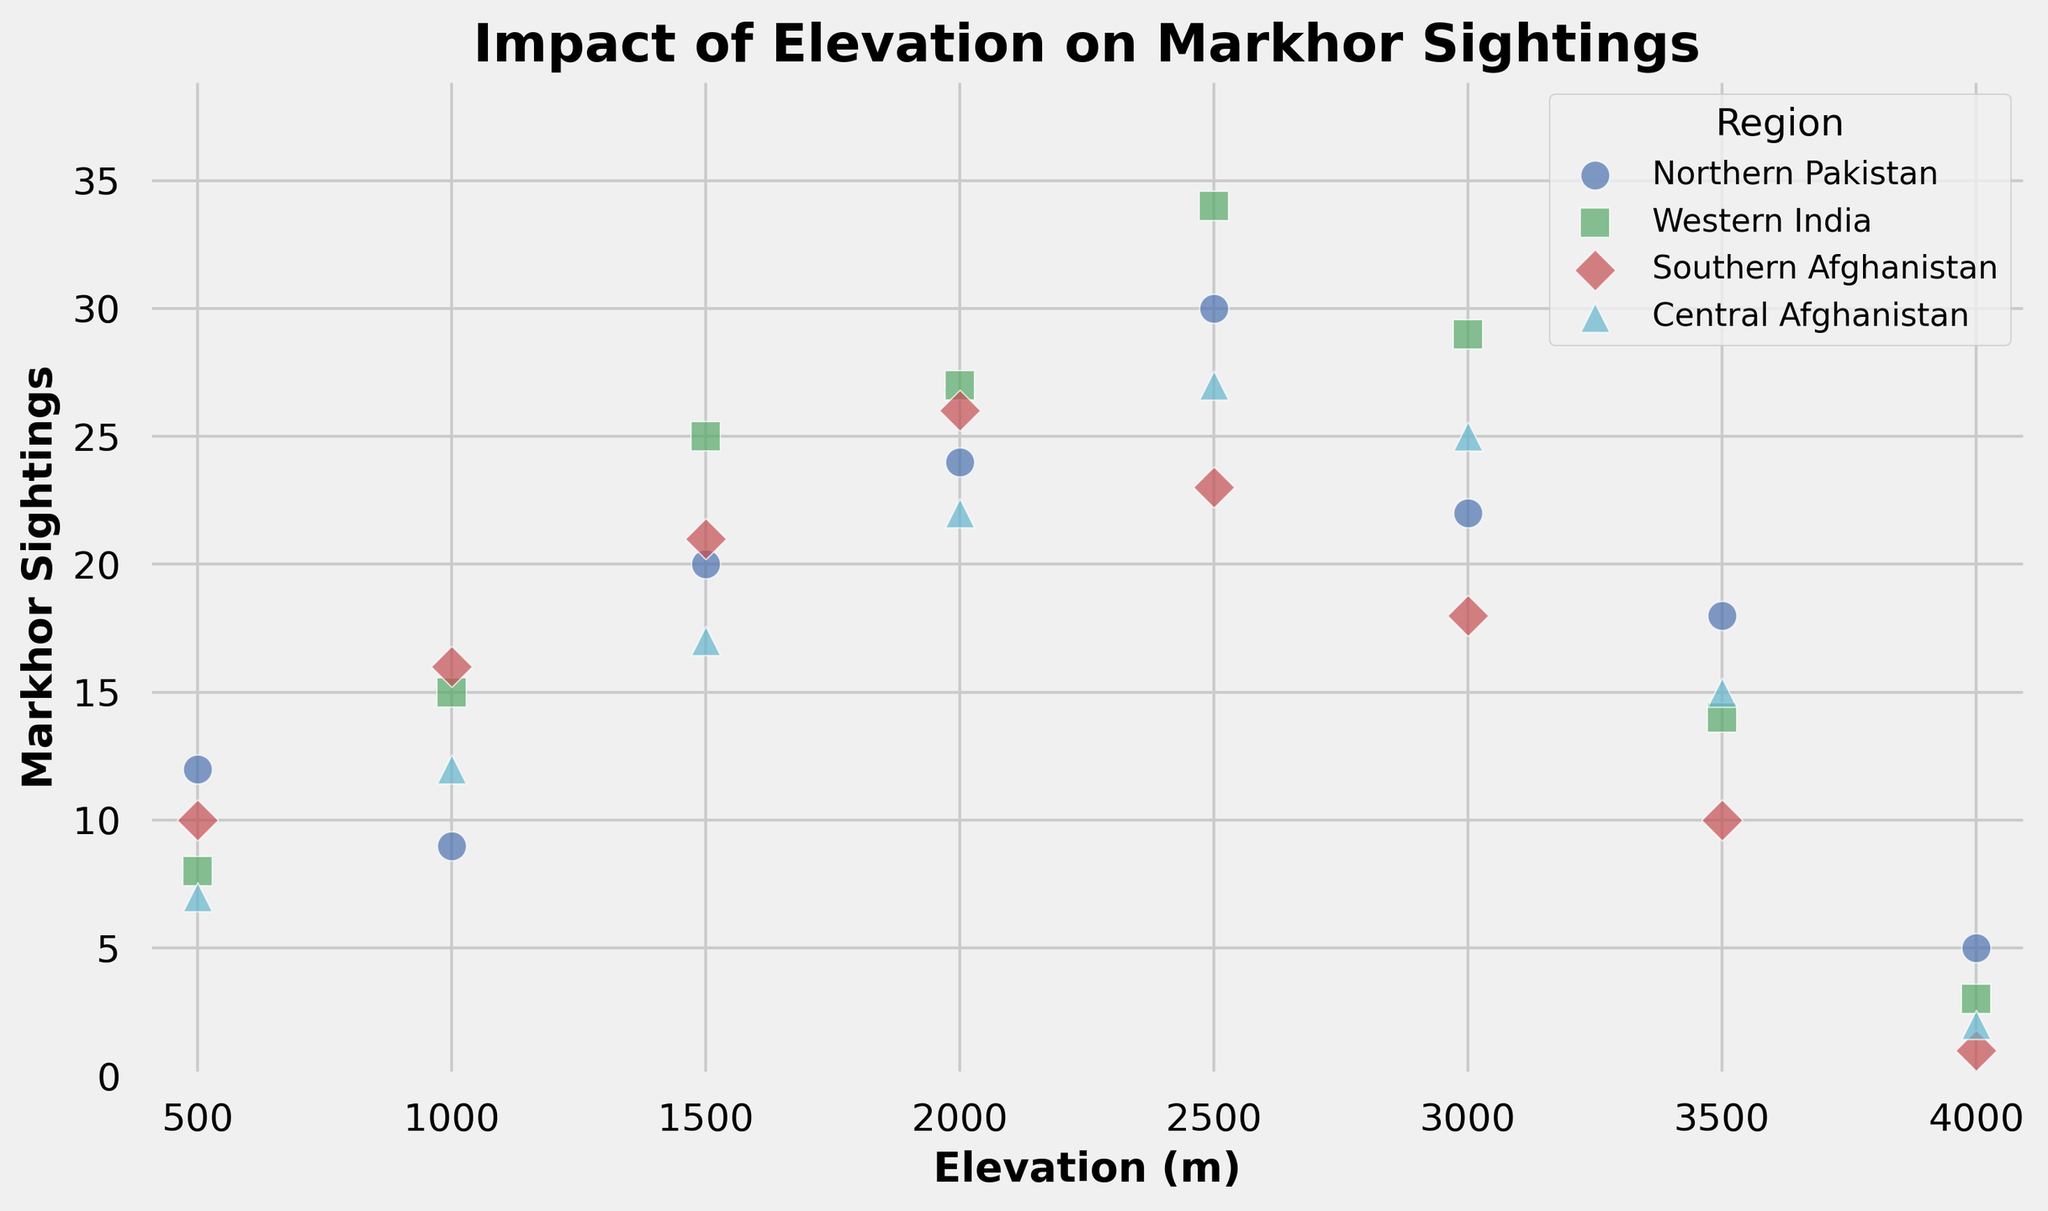What is the general trend in Markhor sightings with increasing elevation in Northern Pakistan? When looking at the scatter plot for Northern Pakistan, the sightings increase from 500m to 2500m, peak at 2500m, then decline after that.
Answer: Increase to a peak, then decrease Among all the regions, which elevation has the highest number of Markhor sightings, and what is that number? By scanning the scatter plot, Western India at 2500m elevation has the highest number of sightings with 34 Markhors.
Answer: Western India at 2500m, 34 sightings How does the number of Markhor sightings at 4000m elevation compare among the four regions? At 4000m elevation, Northern Pakistan has 5 sightings, Western India has 3 sightings, Southern Afghanistan has 1 sighting, and Central Afghanistan has 2 sightings. Therefore, Northern Pakistan has the most sightings at this elevation.
Answer: Northern Pakistan: 5, Western India: 3, Southern Afghanistan: 1, Central Afghanistan: 2 Which region shows the most consistent trend in Markhor sightings with increasing elevation? By evaluating the scatter plot, Central Afghanistan shows a relatively steady increase in sightings up to 3000m, then a decline, which appears more consistent compared to other regions.
Answer: Central Afghanistan Between Southern Afghanistan and Western India, which region has higher Markhor sightings at 1500m and how many more sightings does it have? At 1500m elevation, Western India has 25 sightings and Southern Afghanistan has 21 sightings. The difference is 4 sightings.
Answer: Western India, 4 more sightings What can be said about the Markhor sightings at 1000m elevation across the four regions? At 1000m, Northern Pakistan has 9 sightings, Western India has 15, Southern Afghanistan has 16, and Central Afghanistan has 12. Southern Afghanistan has the highest sightings at this elevation.
Answer: Southern Afghanistan has the highest, with 16 sightings At which elevation does Northern Pakistan see the maximum number of Markhor sightings and what is the count? Northern Pakistan sees the highest number of Markhor sightings at 2500m with a count of 30 sightings.
Answer: 2500m, 30 sightings What trend do you observe in the Western India region beyond 2500m elevation? In Western India, sightings increase until 2500m, peak at 34, then decrease sharply after 2500m.
Answer: Increase to a peak at 2500m, then decrease How do the maximum Markhor sightings of Northern Pakistan and Western India compare? The maximum sightings in Northern Pakistan are 30 at 2500m, while Western India's maximum is 34 at 2500m. Western India's maximum is higher by 4 sightings.
Answer: Western India is higher by 4 sightings 